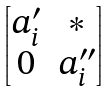<formula> <loc_0><loc_0><loc_500><loc_500>\begin{bmatrix} a _ { i } ^ { \prime } & * \\ 0 & a _ { i } ^ { \prime \prime } \end{bmatrix}</formula> 